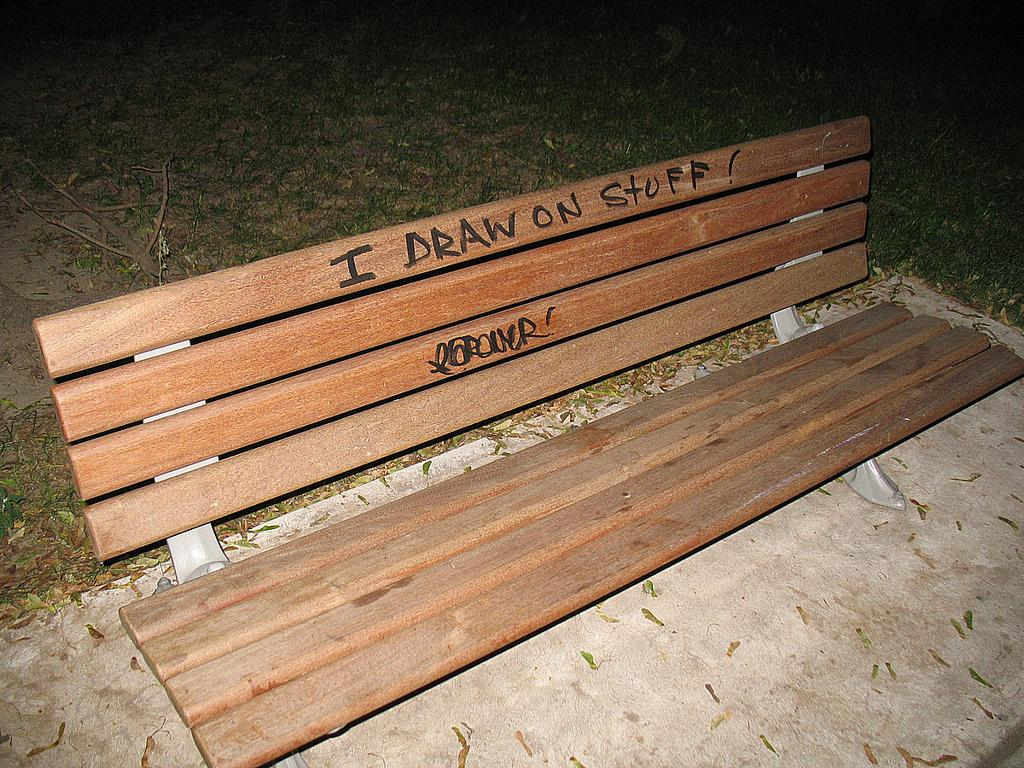What type of seating is visible in the image? There is a bench in the image. Is there any writing or text on the bench? Yes, there is text written on the bench. What can be seen in the background of the image? There is grass on the ground in the background of the image. What type of faucet is present in the image? There is no faucet present in the image. What nation is represented by the text on the bench? The text on the bench does not represent any nation; it is not mentioned in the provided facts. 